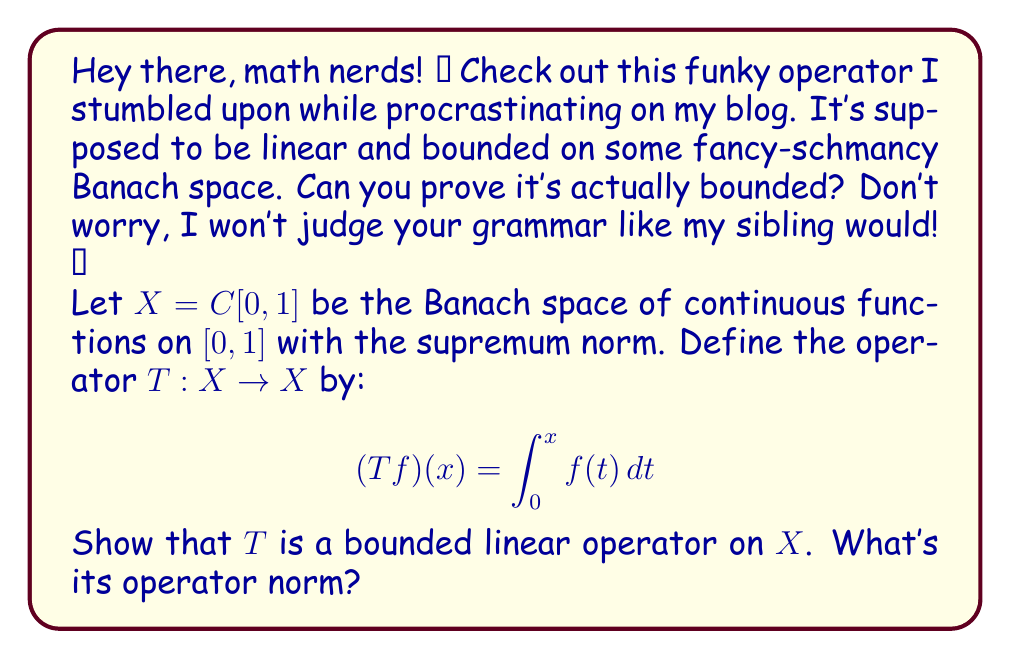What is the answer to this math problem? Alright, let's break this down, no fancy words needed!

1) First, we gotta check if $T$ is linear. For any $f, g \in X$ and scalars $\alpha, \beta$:

   $T(\alpha f + \beta g)(x) = \int_0^x (\alpha f(t) + \beta g(t)) dt$
                             $= \alpha \int_0^x f(t) dt + \beta \int_0^x g(t) dt$
                             $= \alpha (Tf)(x) + \beta (Tg)(x)$

   So, yeah, $T$ is linear. Cool beans!

2) Now, for boundedness, we need to find a constant $M > 0$ such that $\|Tf\| \leq M\|f\|$ for all $f \in X$.

3) Let's look at $|(Tf)(x)|$:

   $|(Tf)(x)| = |\int_0^x f(t) dt| \leq \int_0^x |f(t)| dt \leq \int_0^x \|f\|_{\infty} dt = x\|f\|_{\infty}$

4) Since $x \in [0,1]$, we have $x \leq 1$. So:

   $|(Tf)(x)| \leq \|f\|_{\infty}$

5) This means:

   $\|Tf\|_{\infty} = \sup_{x \in [0,1]} |(Tf)(x)| \leq \|f\|_{\infty}$

6) Therefore, we can choose $M = 1$, and we have:

   $\|Tf\|_{\infty} \leq 1 \cdot \|f\|_{\infty}$

7) This proves that $T$ is bounded, and its operator norm $\|T\|$ is at most 1.

8) To show that $\|T\| = 1$, consider the function $f(x) = 1$ for all $x \in [0,1]$. Then:

   $(Tf)(x) = \int_0^x 1 dt = x$

   $\|Tf\|_{\infty} = \sup_{x \in [0,1]} |x| = 1 = \|f\|_{\infty}$

So, the operator norm is exactly 1. Boom! 💥
Answer: The operator $T$ is indeed a bounded linear operator on $X = C[0,1]$ with the supremum norm. Its operator norm is $\|T\| = 1$. 